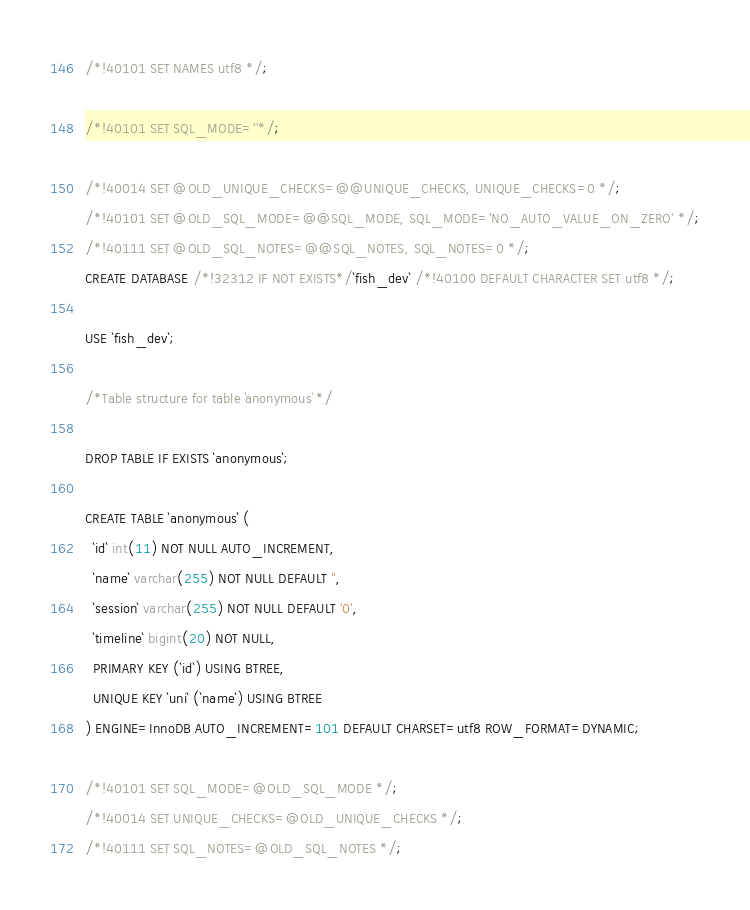<code> <loc_0><loc_0><loc_500><loc_500><_SQL_>
/*!40101 SET NAMES utf8 */;

/*!40101 SET SQL_MODE=''*/;

/*!40014 SET @OLD_UNIQUE_CHECKS=@@UNIQUE_CHECKS, UNIQUE_CHECKS=0 */;
/*!40101 SET @OLD_SQL_MODE=@@SQL_MODE, SQL_MODE='NO_AUTO_VALUE_ON_ZERO' */;
/*!40111 SET @OLD_SQL_NOTES=@@SQL_NOTES, SQL_NOTES=0 */;
CREATE DATABASE /*!32312 IF NOT EXISTS*/`fish_dev` /*!40100 DEFAULT CHARACTER SET utf8 */;

USE `fish_dev`;

/*Table structure for table `anonymous` */

DROP TABLE IF EXISTS `anonymous`;

CREATE TABLE `anonymous` (
  `id` int(11) NOT NULL AUTO_INCREMENT,
  `name` varchar(255) NOT NULL DEFAULT '',
  `session` varchar(255) NOT NULL DEFAULT '0',
  `timeline` bigint(20) NOT NULL,
  PRIMARY KEY (`id`) USING BTREE,
  UNIQUE KEY `uni` (`name`) USING BTREE
) ENGINE=InnoDB AUTO_INCREMENT=101 DEFAULT CHARSET=utf8 ROW_FORMAT=DYNAMIC;

/*!40101 SET SQL_MODE=@OLD_SQL_MODE */;
/*!40014 SET UNIQUE_CHECKS=@OLD_UNIQUE_CHECKS */;
/*!40111 SET SQL_NOTES=@OLD_SQL_NOTES */;
</code> 